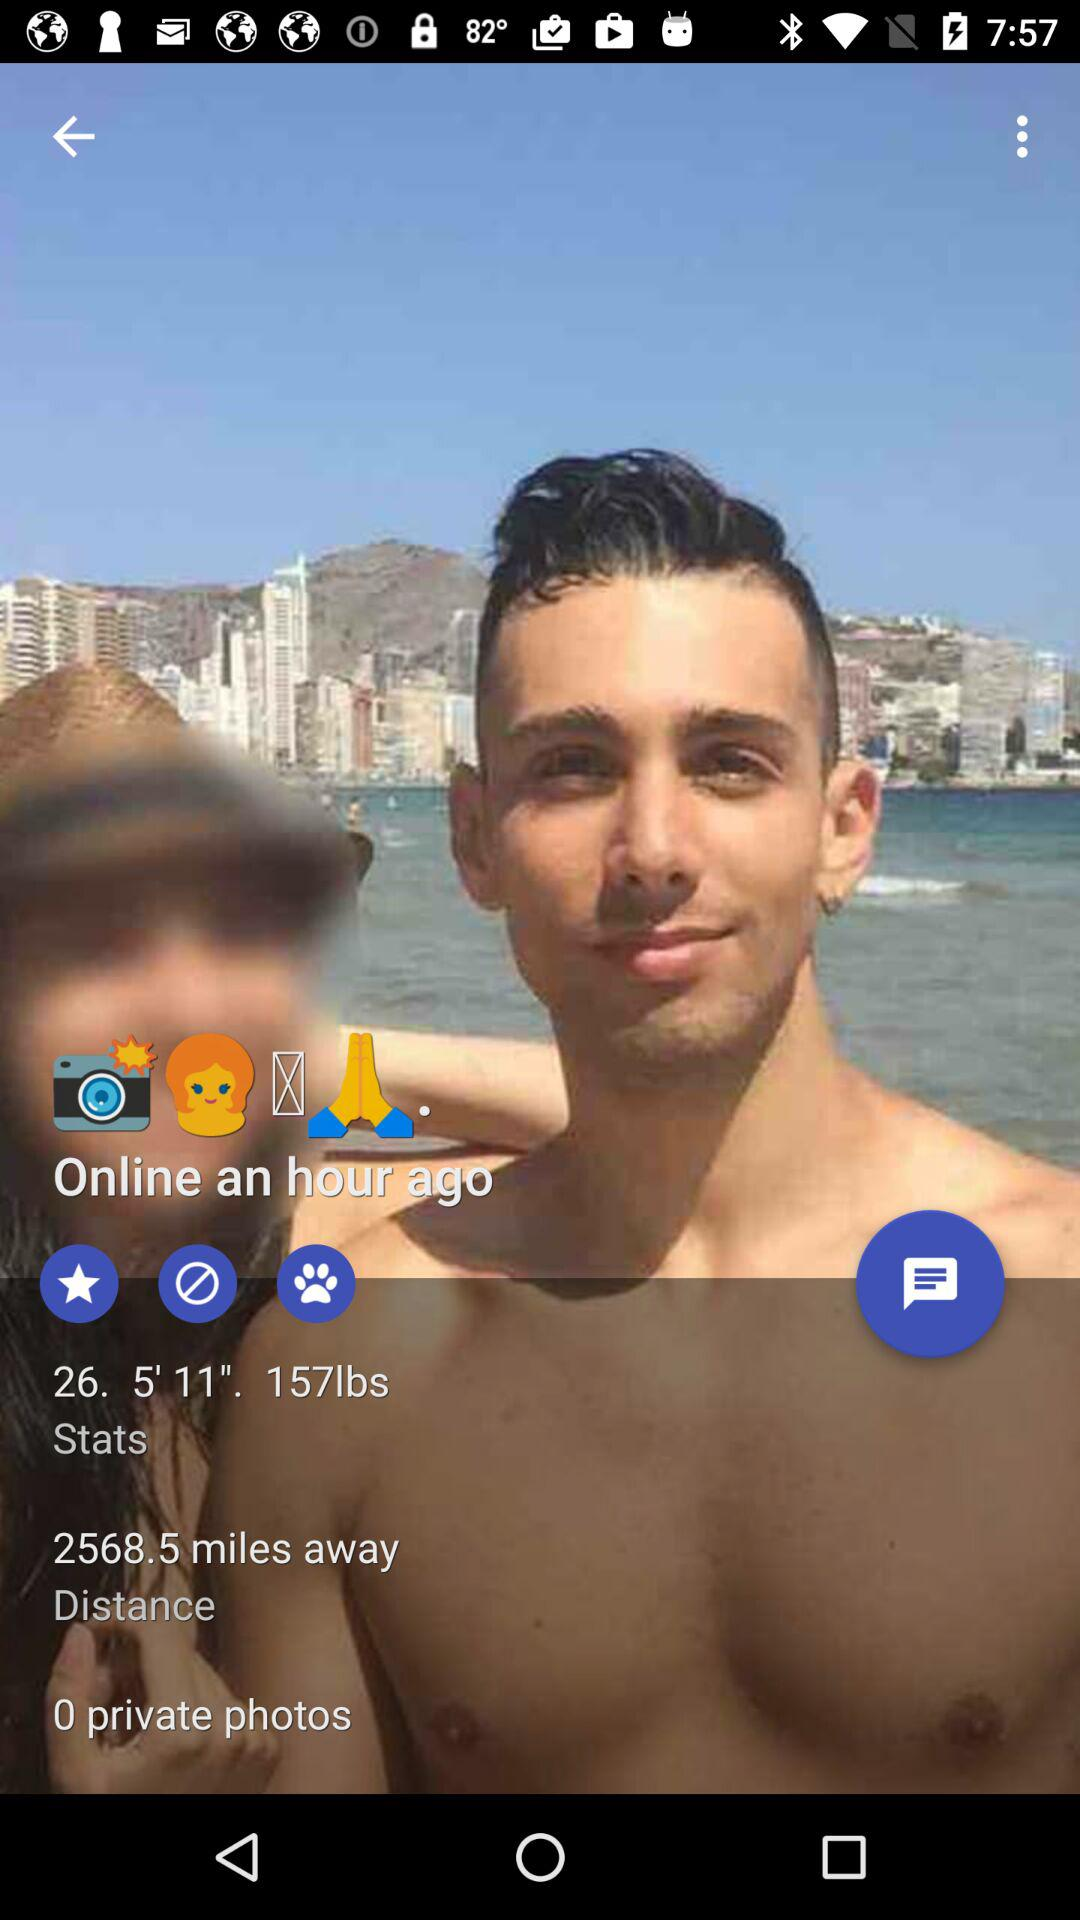How tall is the user? The user is 5'11" tall. 